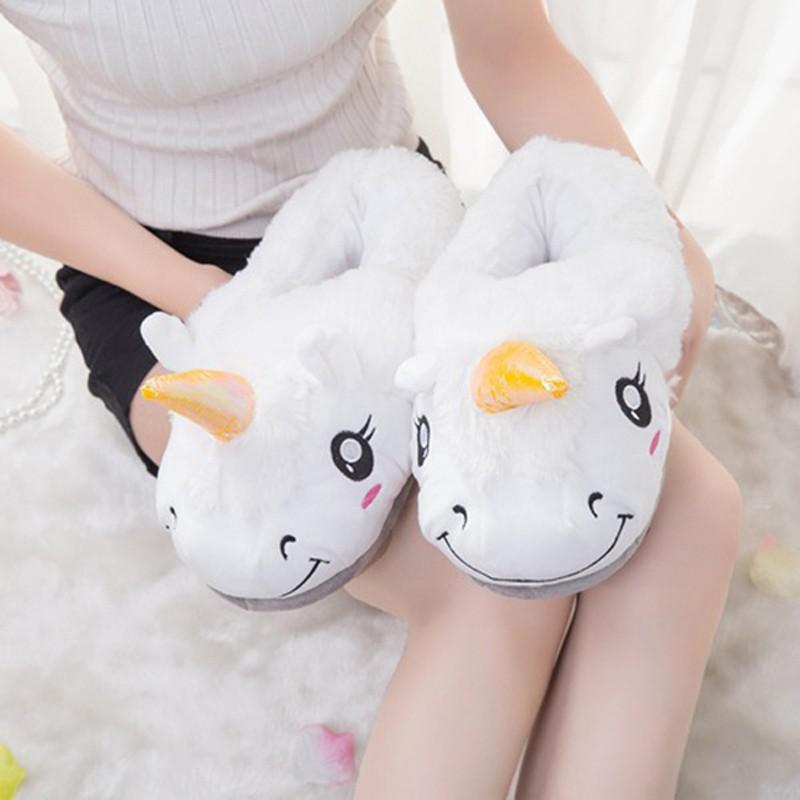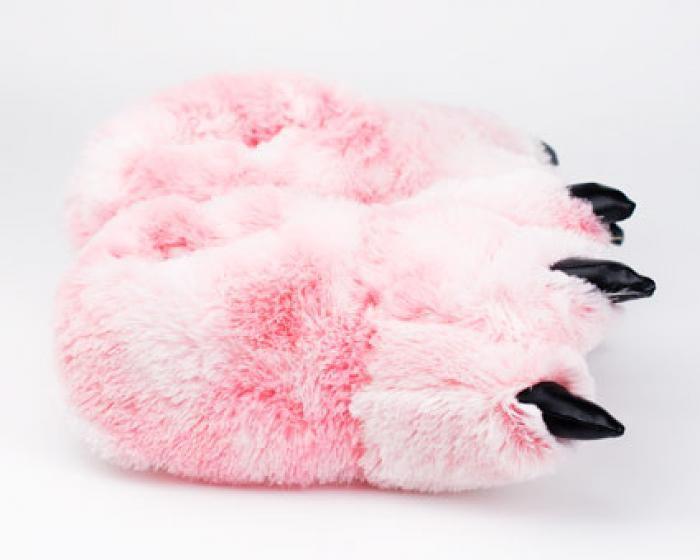The first image is the image on the left, the second image is the image on the right. Given the left and right images, does the statement "there are two pair of punny slippers in the image pair" hold true? Answer yes or no. No. The first image is the image on the left, the second image is the image on the right. For the images displayed, is the sentence "The combined images include two pairs of fuzzy slippers with bunny-rabbit faces." factually correct? Answer yes or no. No. 